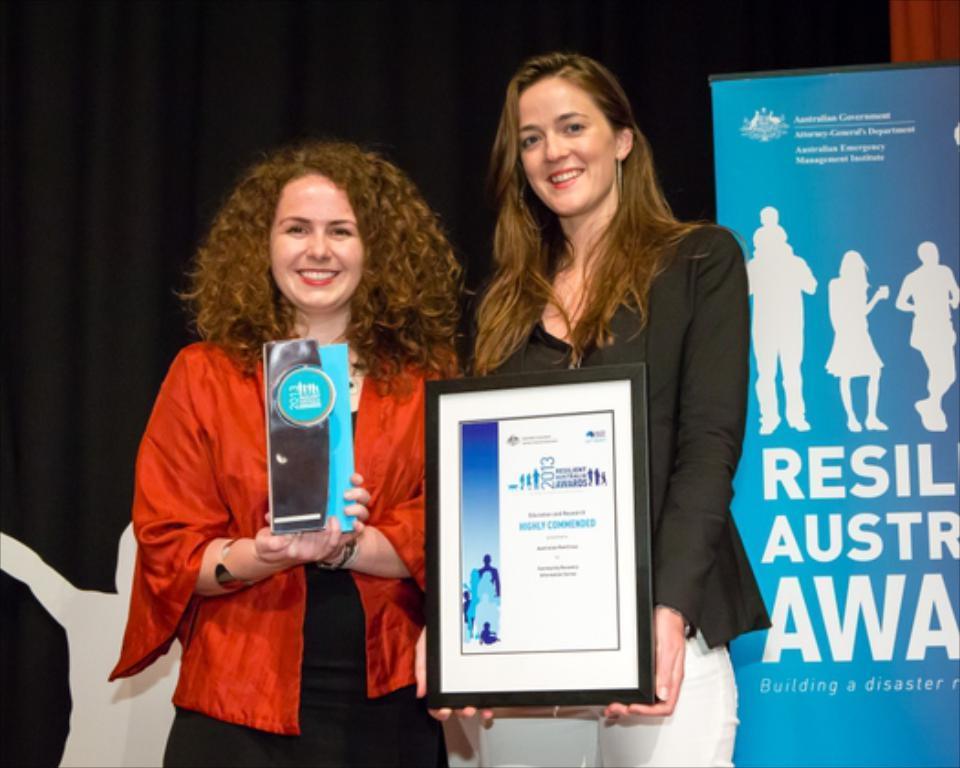Describe this image in one or two sentences. In the picture I can see two women and there is a pretty smile on their faces. I can see a woman on the left side is holding the advertising product in her hands and another woman on the right side is holding the momentum shield in her hands. There is a hoarding on the right side. In the background, I can see the curtain. 